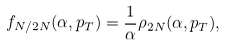Convert formula to latex. <formula><loc_0><loc_0><loc_500><loc_500>f _ { N / 2 N } ( \alpha , p _ { T } ) = \frac { 1 } { \alpha } \rho _ { 2 N } ( \alpha , p _ { T } ) ,</formula> 